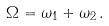<formula> <loc_0><loc_0><loc_500><loc_500>\Omega = \omega _ { 1 } + \omega _ { 2 } \, .</formula> 